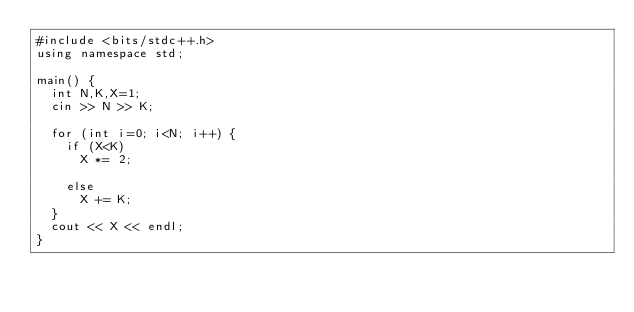Convert code to text. <code><loc_0><loc_0><loc_500><loc_500><_C++_>#include <bits/stdc++.h>
using namespace std;

main() {
  int N,K,X=1;
  cin >> N >> K;
  
  for (int i=0; i<N; i++) {
    if (X<K) 
      X *= 2;
    
    else 
      X += K;
  }
  cout << X << endl;
}      </code> 